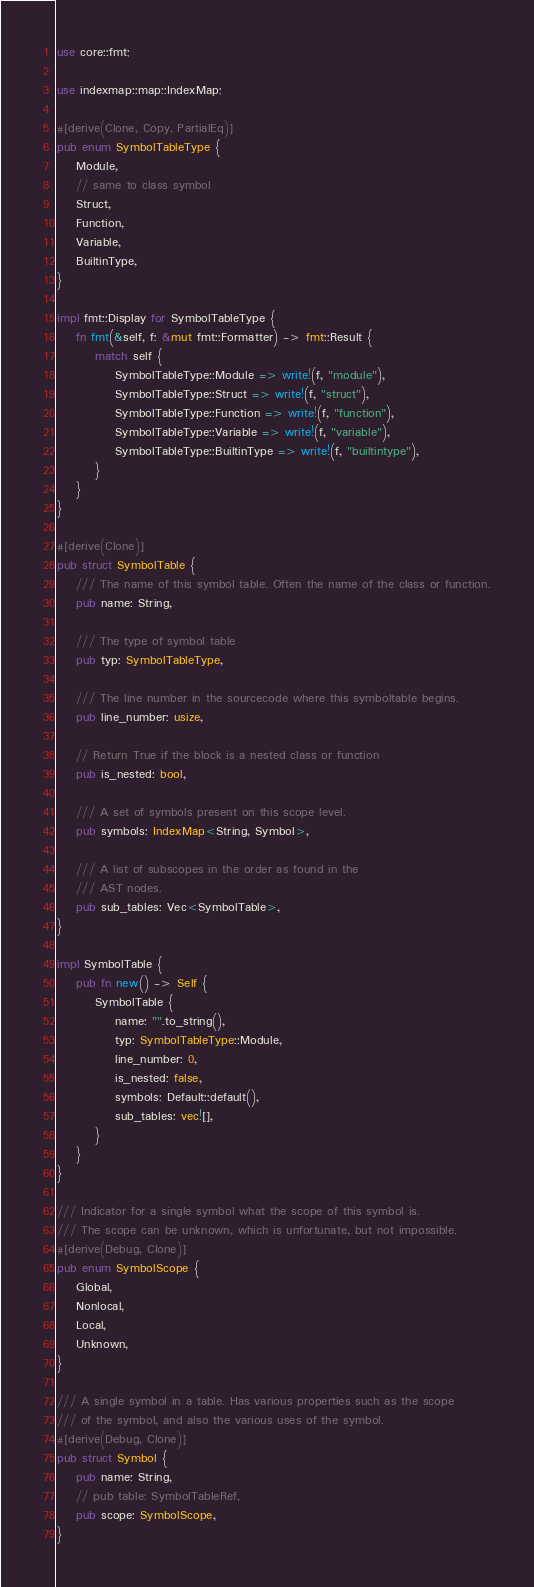<code> <loc_0><loc_0><loc_500><loc_500><_Rust_>use core::fmt;

use indexmap::map::IndexMap;

#[derive(Clone, Copy, PartialEq)]
pub enum SymbolTableType {
    Module,
    // same to class symbol
    Struct,
    Function,
    Variable,
    BuiltinType,
}

impl fmt::Display for SymbolTableType {
    fn fmt(&self, f: &mut fmt::Formatter) -> fmt::Result {
        match self {
            SymbolTableType::Module => write!(f, "module"),
            SymbolTableType::Struct => write!(f, "struct"),
            SymbolTableType::Function => write!(f, "function"),
            SymbolTableType::Variable => write!(f, "variable"),
            SymbolTableType::BuiltinType => write!(f, "builtintype"),
        }
    }
}

#[derive(Clone)]
pub struct SymbolTable {
    /// The name of this symbol table. Often the name of the class or function.
    pub name: String,

    /// The type of symbol table
    pub typ: SymbolTableType,

    /// The line number in the sourcecode where this symboltable begins.
    pub line_number: usize,

    // Return True if the block is a nested class or function
    pub is_nested: bool,

    /// A set of symbols present on this scope level.
    pub symbols: IndexMap<String, Symbol>,

    /// A list of subscopes in the order as found in the
    /// AST nodes.
    pub sub_tables: Vec<SymbolTable>,
}

impl SymbolTable {
    pub fn new() -> Self {
        SymbolTable {
            name: "".to_string(),
            typ: SymbolTableType::Module,
            line_number: 0,
            is_nested: false,
            symbols: Default::default(),
            sub_tables: vec![],
        }
    }
}

/// Indicator for a single symbol what the scope of this symbol is.
/// The scope can be unknown, which is unfortunate, but not impossible.
#[derive(Debug, Clone)]
pub enum SymbolScope {
    Global,
    Nonlocal,
    Local,
    Unknown,
}

/// A single symbol in a table. Has various properties such as the scope
/// of the symbol, and also the various uses of the symbol.
#[derive(Debug, Clone)]
pub struct Symbol {
    pub name: String,
    // pub table: SymbolTableRef,
    pub scope: SymbolScope,
}
</code> 